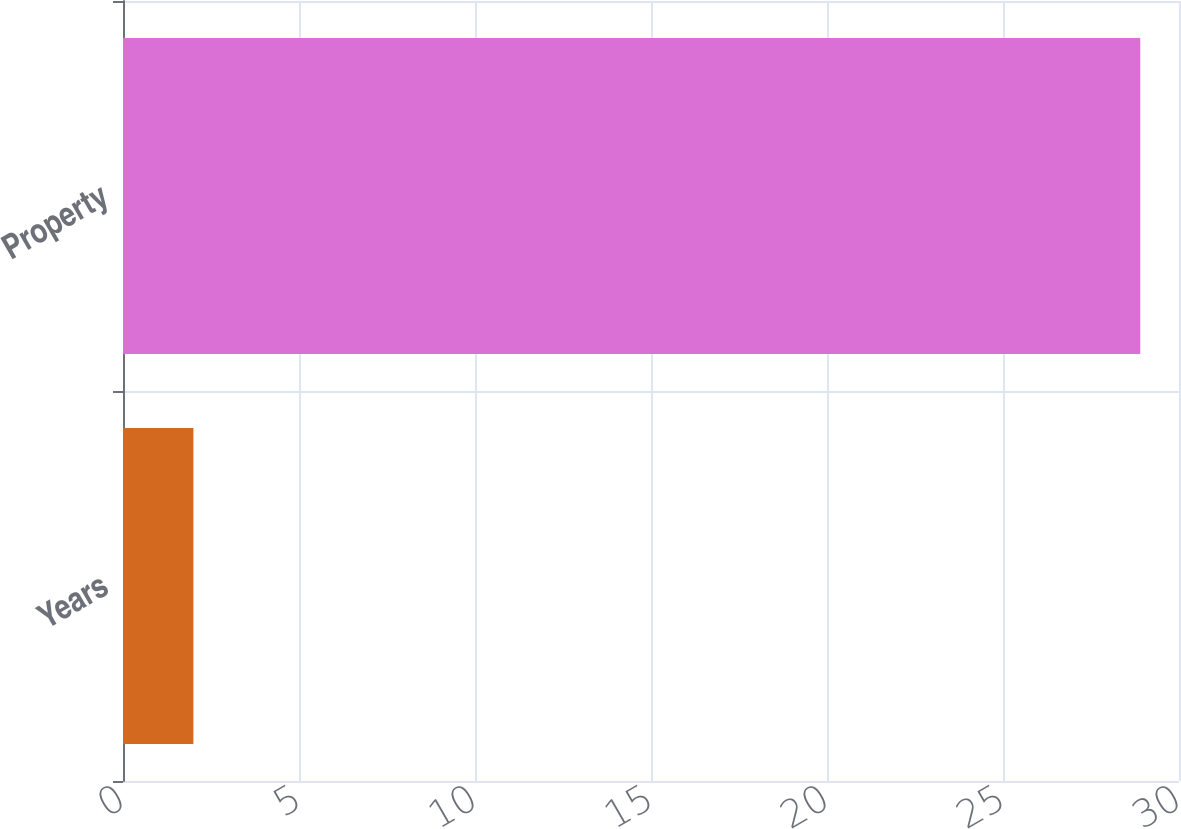Convert chart. <chart><loc_0><loc_0><loc_500><loc_500><bar_chart><fcel>Years<fcel>Property<nl><fcel>2<fcel>28.9<nl></chart> 